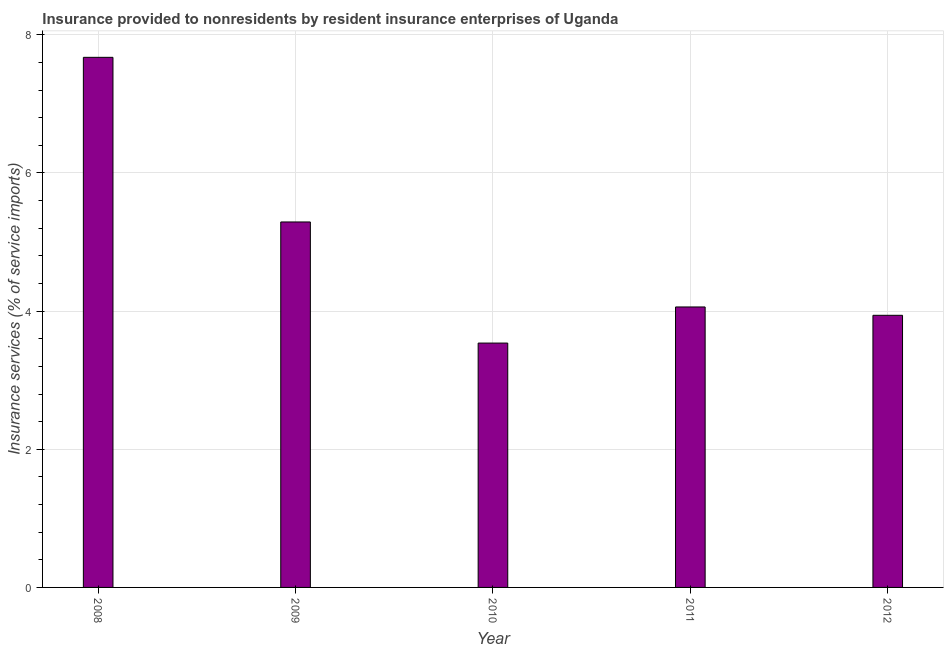What is the title of the graph?
Keep it short and to the point. Insurance provided to nonresidents by resident insurance enterprises of Uganda. What is the label or title of the Y-axis?
Provide a succinct answer. Insurance services (% of service imports). What is the insurance and financial services in 2008?
Your response must be concise. 7.67. Across all years, what is the maximum insurance and financial services?
Your answer should be compact. 7.67. Across all years, what is the minimum insurance and financial services?
Your answer should be very brief. 3.54. In which year was the insurance and financial services maximum?
Give a very brief answer. 2008. What is the sum of the insurance and financial services?
Keep it short and to the point. 24.5. What is the difference between the insurance and financial services in 2009 and 2010?
Offer a terse response. 1.75. What is the median insurance and financial services?
Provide a short and direct response. 4.06. In how many years, is the insurance and financial services greater than 6.4 %?
Make the answer very short. 1. What is the ratio of the insurance and financial services in 2009 to that in 2012?
Offer a very short reply. 1.34. What is the difference between the highest and the second highest insurance and financial services?
Your answer should be compact. 2.38. Is the sum of the insurance and financial services in 2008 and 2010 greater than the maximum insurance and financial services across all years?
Keep it short and to the point. Yes. What is the difference between the highest and the lowest insurance and financial services?
Keep it short and to the point. 4.14. Are all the bars in the graph horizontal?
Provide a short and direct response. No. How many years are there in the graph?
Make the answer very short. 5. What is the difference between two consecutive major ticks on the Y-axis?
Offer a very short reply. 2. What is the Insurance services (% of service imports) in 2008?
Your answer should be very brief. 7.67. What is the Insurance services (% of service imports) in 2009?
Offer a terse response. 5.29. What is the Insurance services (% of service imports) in 2010?
Your answer should be very brief. 3.54. What is the Insurance services (% of service imports) of 2011?
Offer a very short reply. 4.06. What is the Insurance services (% of service imports) of 2012?
Ensure brevity in your answer.  3.94. What is the difference between the Insurance services (% of service imports) in 2008 and 2009?
Provide a succinct answer. 2.38. What is the difference between the Insurance services (% of service imports) in 2008 and 2010?
Offer a terse response. 4.14. What is the difference between the Insurance services (% of service imports) in 2008 and 2011?
Keep it short and to the point. 3.61. What is the difference between the Insurance services (% of service imports) in 2008 and 2012?
Provide a short and direct response. 3.73. What is the difference between the Insurance services (% of service imports) in 2009 and 2010?
Your answer should be very brief. 1.75. What is the difference between the Insurance services (% of service imports) in 2009 and 2011?
Your answer should be compact. 1.23. What is the difference between the Insurance services (% of service imports) in 2009 and 2012?
Give a very brief answer. 1.35. What is the difference between the Insurance services (% of service imports) in 2010 and 2011?
Provide a short and direct response. -0.52. What is the difference between the Insurance services (% of service imports) in 2010 and 2012?
Offer a very short reply. -0.4. What is the difference between the Insurance services (% of service imports) in 2011 and 2012?
Ensure brevity in your answer.  0.12. What is the ratio of the Insurance services (% of service imports) in 2008 to that in 2009?
Offer a terse response. 1.45. What is the ratio of the Insurance services (% of service imports) in 2008 to that in 2010?
Make the answer very short. 2.17. What is the ratio of the Insurance services (% of service imports) in 2008 to that in 2011?
Give a very brief answer. 1.89. What is the ratio of the Insurance services (% of service imports) in 2008 to that in 2012?
Give a very brief answer. 1.95. What is the ratio of the Insurance services (% of service imports) in 2009 to that in 2010?
Offer a terse response. 1.5. What is the ratio of the Insurance services (% of service imports) in 2009 to that in 2011?
Make the answer very short. 1.3. What is the ratio of the Insurance services (% of service imports) in 2009 to that in 2012?
Ensure brevity in your answer.  1.34. What is the ratio of the Insurance services (% of service imports) in 2010 to that in 2011?
Provide a succinct answer. 0.87. What is the ratio of the Insurance services (% of service imports) in 2010 to that in 2012?
Ensure brevity in your answer.  0.9. What is the ratio of the Insurance services (% of service imports) in 2011 to that in 2012?
Offer a terse response. 1.03. 